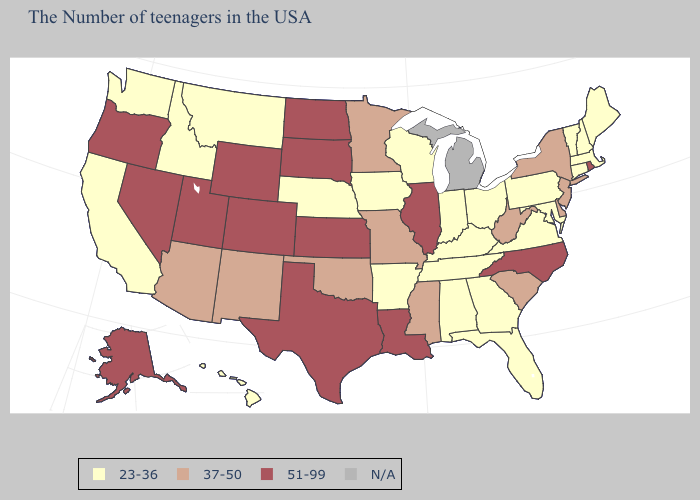Does Missouri have the highest value in the MidWest?
Write a very short answer. No. What is the lowest value in states that border Pennsylvania?
Short answer required. 23-36. What is the value of Iowa?
Write a very short answer. 23-36. Name the states that have a value in the range 51-99?
Concise answer only. Rhode Island, North Carolina, Illinois, Louisiana, Kansas, Texas, South Dakota, North Dakota, Wyoming, Colorado, Utah, Nevada, Oregon, Alaska. What is the lowest value in the USA?
Write a very short answer. 23-36. Does the map have missing data?
Answer briefly. Yes. What is the value of New York?
Answer briefly. 37-50. Name the states that have a value in the range N/A?
Give a very brief answer. Michigan. Name the states that have a value in the range 37-50?
Keep it brief. New York, New Jersey, Delaware, South Carolina, West Virginia, Mississippi, Missouri, Minnesota, Oklahoma, New Mexico, Arizona. How many symbols are there in the legend?
Be succinct. 4. What is the value of New Mexico?
Write a very short answer. 37-50. What is the highest value in the Northeast ?
Be succinct. 51-99. Does Massachusetts have the lowest value in the USA?
Concise answer only. Yes. How many symbols are there in the legend?
Be succinct. 4. 